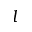<formula> <loc_0><loc_0><loc_500><loc_500>l</formula> 